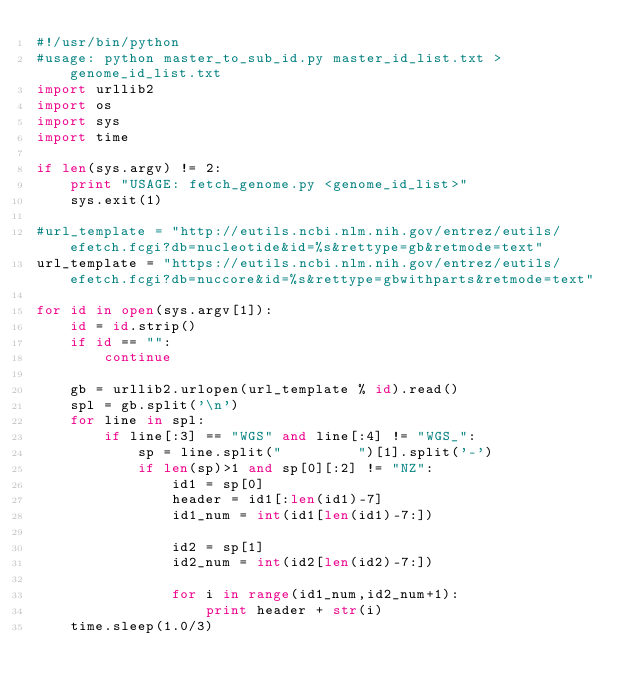<code> <loc_0><loc_0><loc_500><loc_500><_Python_>#!/usr/bin/python
#usage: python master_to_sub_id.py master_id_list.txt > genome_id_list.txt
import urllib2
import os
import sys
import time

if len(sys.argv) != 2:
    print "USAGE: fetch_genome.py <genome_id_list>"
    sys.exit(1)

#url_template = "http://eutils.ncbi.nlm.nih.gov/entrez/eutils/efetch.fcgi?db=nucleotide&id=%s&rettype=gb&retmode=text"
url_template = "https://eutils.ncbi.nlm.nih.gov/entrez/eutils/efetch.fcgi?db=nuccore&id=%s&rettype=gbwithparts&retmode=text"

for id in open(sys.argv[1]):
    id = id.strip()
    if id == "":
        continue

    gb = urllib2.urlopen(url_template % id).read()
    spl = gb.split('\n')
    for line in spl:
        if line[:3] == "WGS" and line[:4] != "WGS_":
            sp = line.split("         ")[1].split('-')
            if len(sp)>1 and sp[0][:2] != "NZ":
                id1 = sp[0]
                header = id1[:len(id1)-7]
                id1_num = int(id1[len(id1)-7:])
            
                id2 = sp[1]
                id2_num = int(id2[len(id2)-7:])
            
                for i in range(id1_num,id2_num+1):
                    print header + str(i)
    time.sleep(1.0/3)
 
</code> 